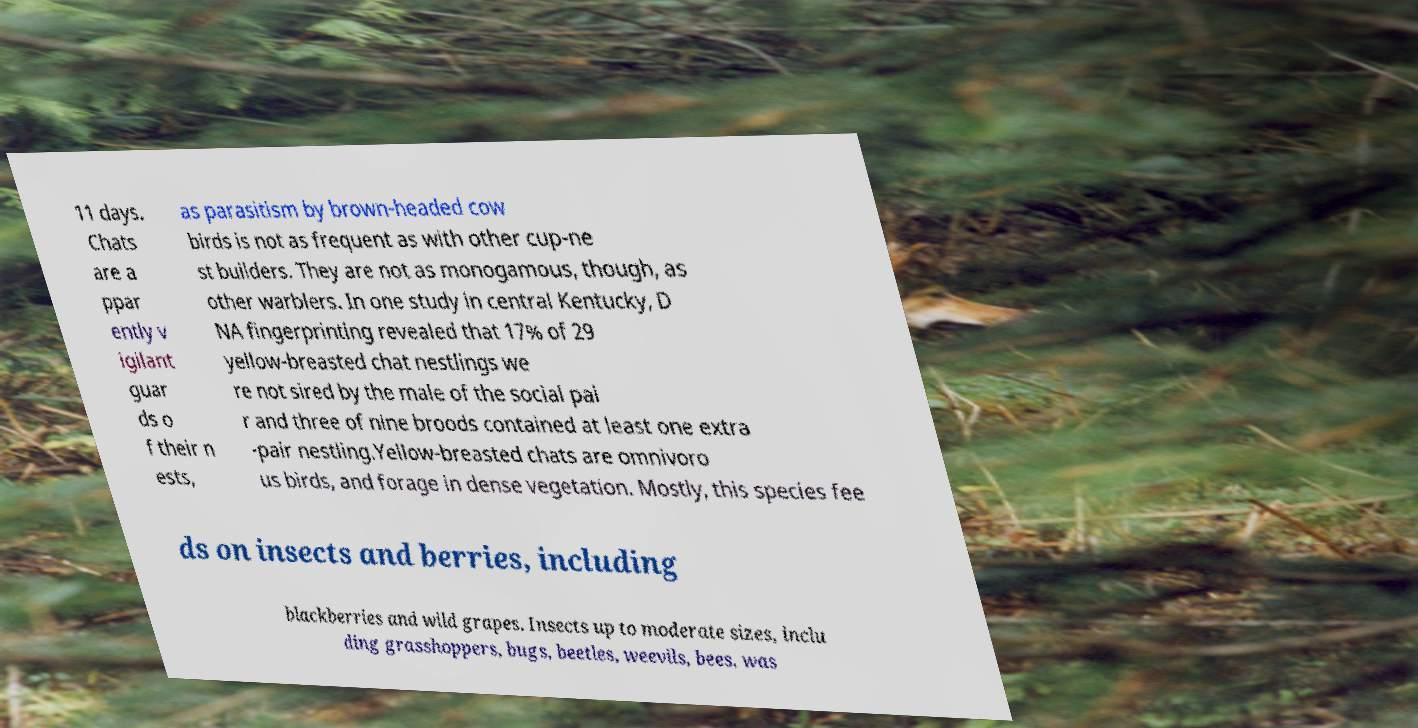Could you assist in decoding the text presented in this image and type it out clearly? 11 days. Chats are a ppar ently v igilant guar ds o f their n ests, as parasitism by brown-headed cow birds is not as frequent as with other cup-ne st builders. They are not as monogamous, though, as other warblers. In one study in central Kentucky, D NA fingerprinting revealed that 17% of 29 yellow-breasted chat nestlings we re not sired by the male of the social pai r and three of nine broods contained at least one extra -pair nestling.Yellow-breasted chats are omnivoro us birds, and forage in dense vegetation. Mostly, this species fee ds on insects and berries, including blackberries and wild grapes. Insects up to moderate sizes, inclu ding grasshoppers, bugs, beetles, weevils, bees, was 